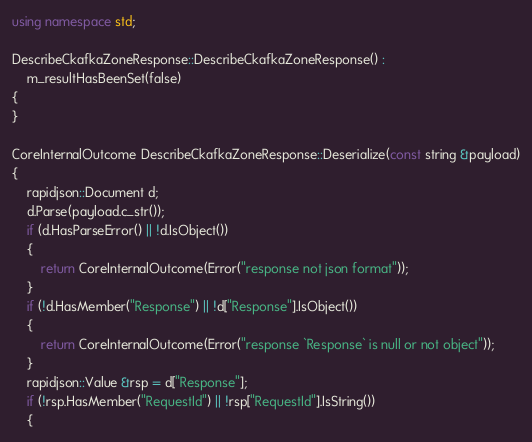<code> <loc_0><loc_0><loc_500><loc_500><_C++_>using namespace std;

DescribeCkafkaZoneResponse::DescribeCkafkaZoneResponse() :
    m_resultHasBeenSet(false)
{
}

CoreInternalOutcome DescribeCkafkaZoneResponse::Deserialize(const string &payload)
{
    rapidjson::Document d;
    d.Parse(payload.c_str());
    if (d.HasParseError() || !d.IsObject())
    {
        return CoreInternalOutcome(Error("response not json format"));
    }
    if (!d.HasMember("Response") || !d["Response"].IsObject())
    {
        return CoreInternalOutcome(Error("response `Response` is null or not object"));
    }
    rapidjson::Value &rsp = d["Response"];
    if (!rsp.HasMember("RequestId") || !rsp["RequestId"].IsString())
    {</code> 